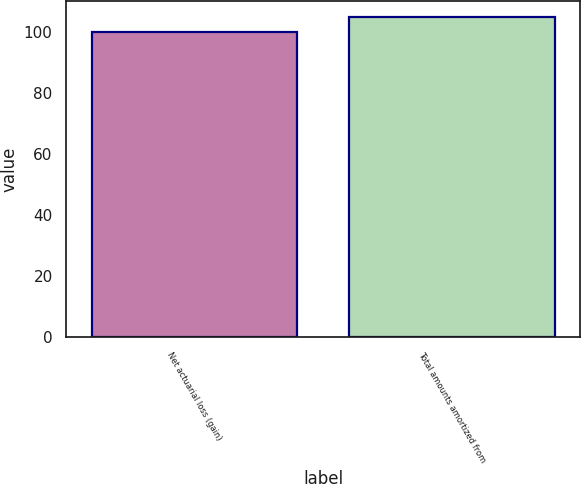Convert chart to OTSL. <chart><loc_0><loc_0><loc_500><loc_500><bar_chart><fcel>Net actuarial loss (gain)<fcel>Total amounts amortized from<nl><fcel>100<fcel>105<nl></chart> 